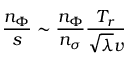Convert formula to latex. <formula><loc_0><loc_0><loc_500><loc_500>\frac { n _ { \Phi } } { s } \sim \frac { n _ { \Phi } } { n _ { \sigma } } \frac { T _ { r } } { \sqrt { \lambda } v }</formula> 